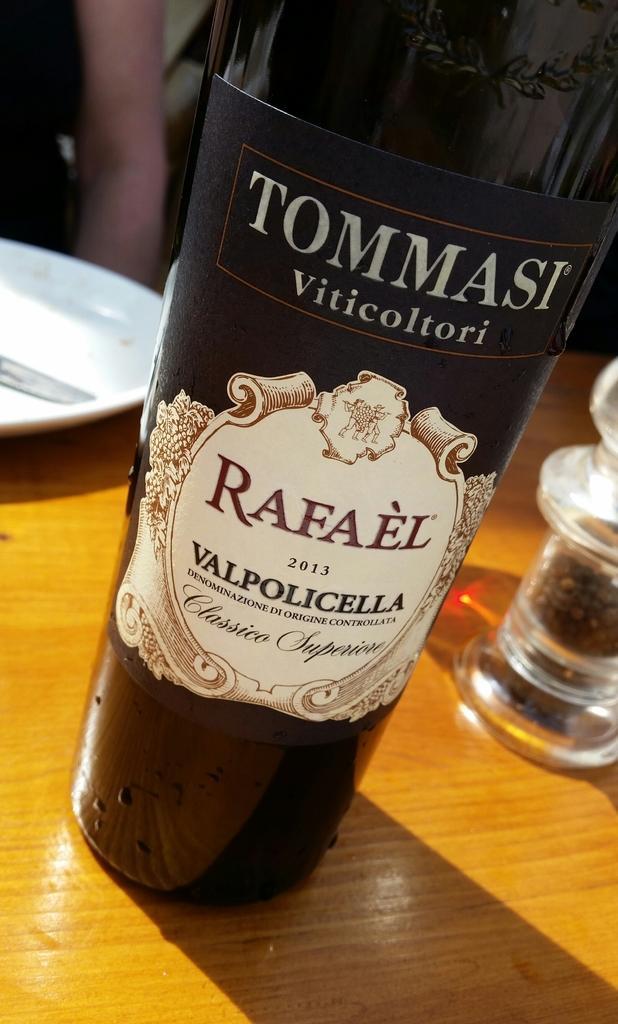Describe this image in one or two sentences. This picture shows a wine bottle and a plate on the table. 